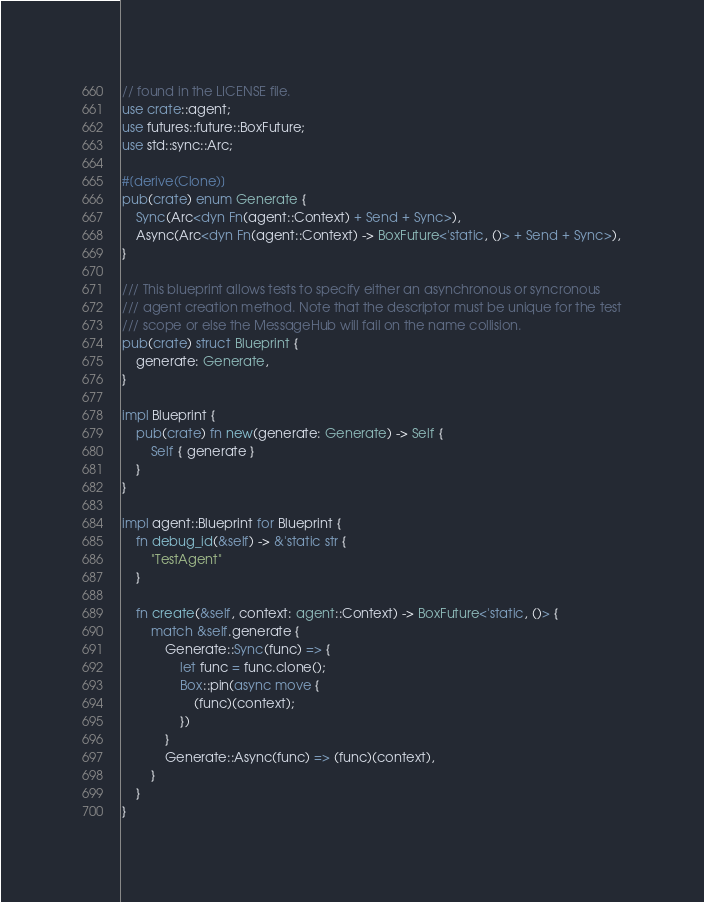Convert code to text. <code><loc_0><loc_0><loc_500><loc_500><_Rust_>// found in the LICENSE file.
use crate::agent;
use futures::future::BoxFuture;
use std::sync::Arc;

#[derive(Clone)]
pub(crate) enum Generate {
    Sync(Arc<dyn Fn(agent::Context) + Send + Sync>),
    Async(Arc<dyn Fn(agent::Context) -> BoxFuture<'static, ()> + Send + Sync>),
}

/// This blueprint allows tests to specify either an asynchronous or syncronous
/// agent creation method. Note that the descriptor must be unique for the test
/// scope or else the MessageHub will fail on the name collision.
pub(crate) struct Blueprint {
    generate: Generate,
}

impl Blueprint {
    pub(crate) fn new(generate: Generate) -> Self {
        Self { generate }
    }
}

impl agent::Blueprint for Blueprint {
    fn debug_id(&self) -> &'static str {
        "TestAgent"
    }

    fn create(&self, context: agent::Context) -> BoxFuture<'static, ()> {
        match &self.generate {
            Generate::Sync(func) => {
                let func = func.clone();
                Box::pin(async move {
                    (func)(context);
                })
            }
            Generate::Async(func) => (func)(context),
        }
    }
}
</code> 